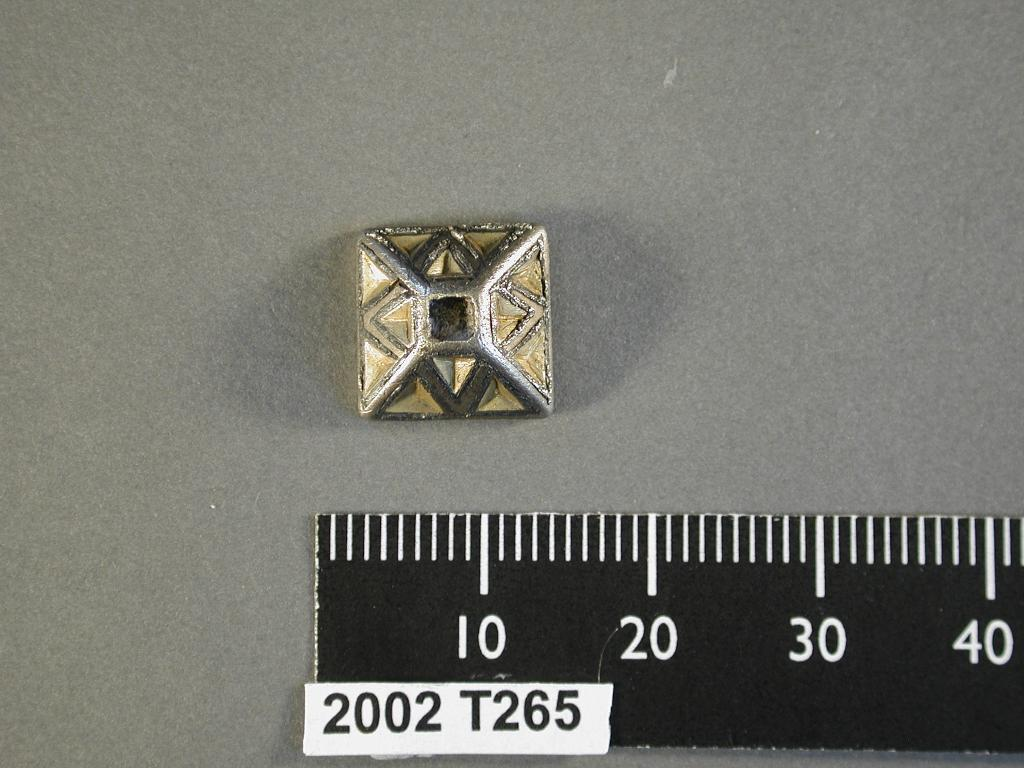<image>
Describe the image concisely. A ruler labeled 2002 T265 lays next to a gold colored pyramid shaped object. 